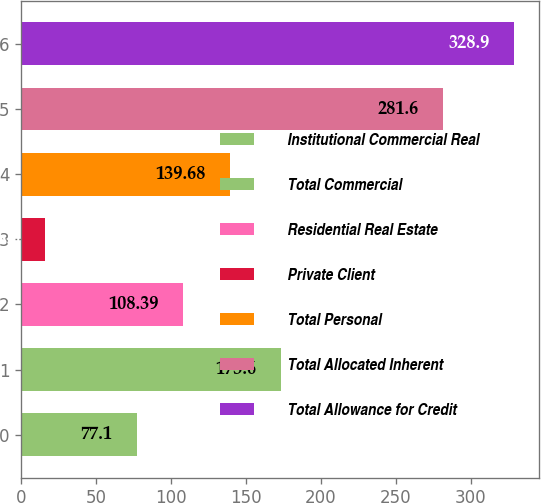<chart> <loc_0><loc_0><loc_500><loc_500><bar_chart><fcel>Institutional Commercial Real<fcel>Total Commercial<fcel>Residential Real Estate<fcel>Private Client<fcel>Total Personal<fcel>Total Allocated Inherent<fcel>Total Allowance for Credit<nl><fcel>77.1<fcel>173.6<fcel>108.39<fcel>16<fcel>139.68<fcel>281.6<fcel>328.9<nl></chart> 